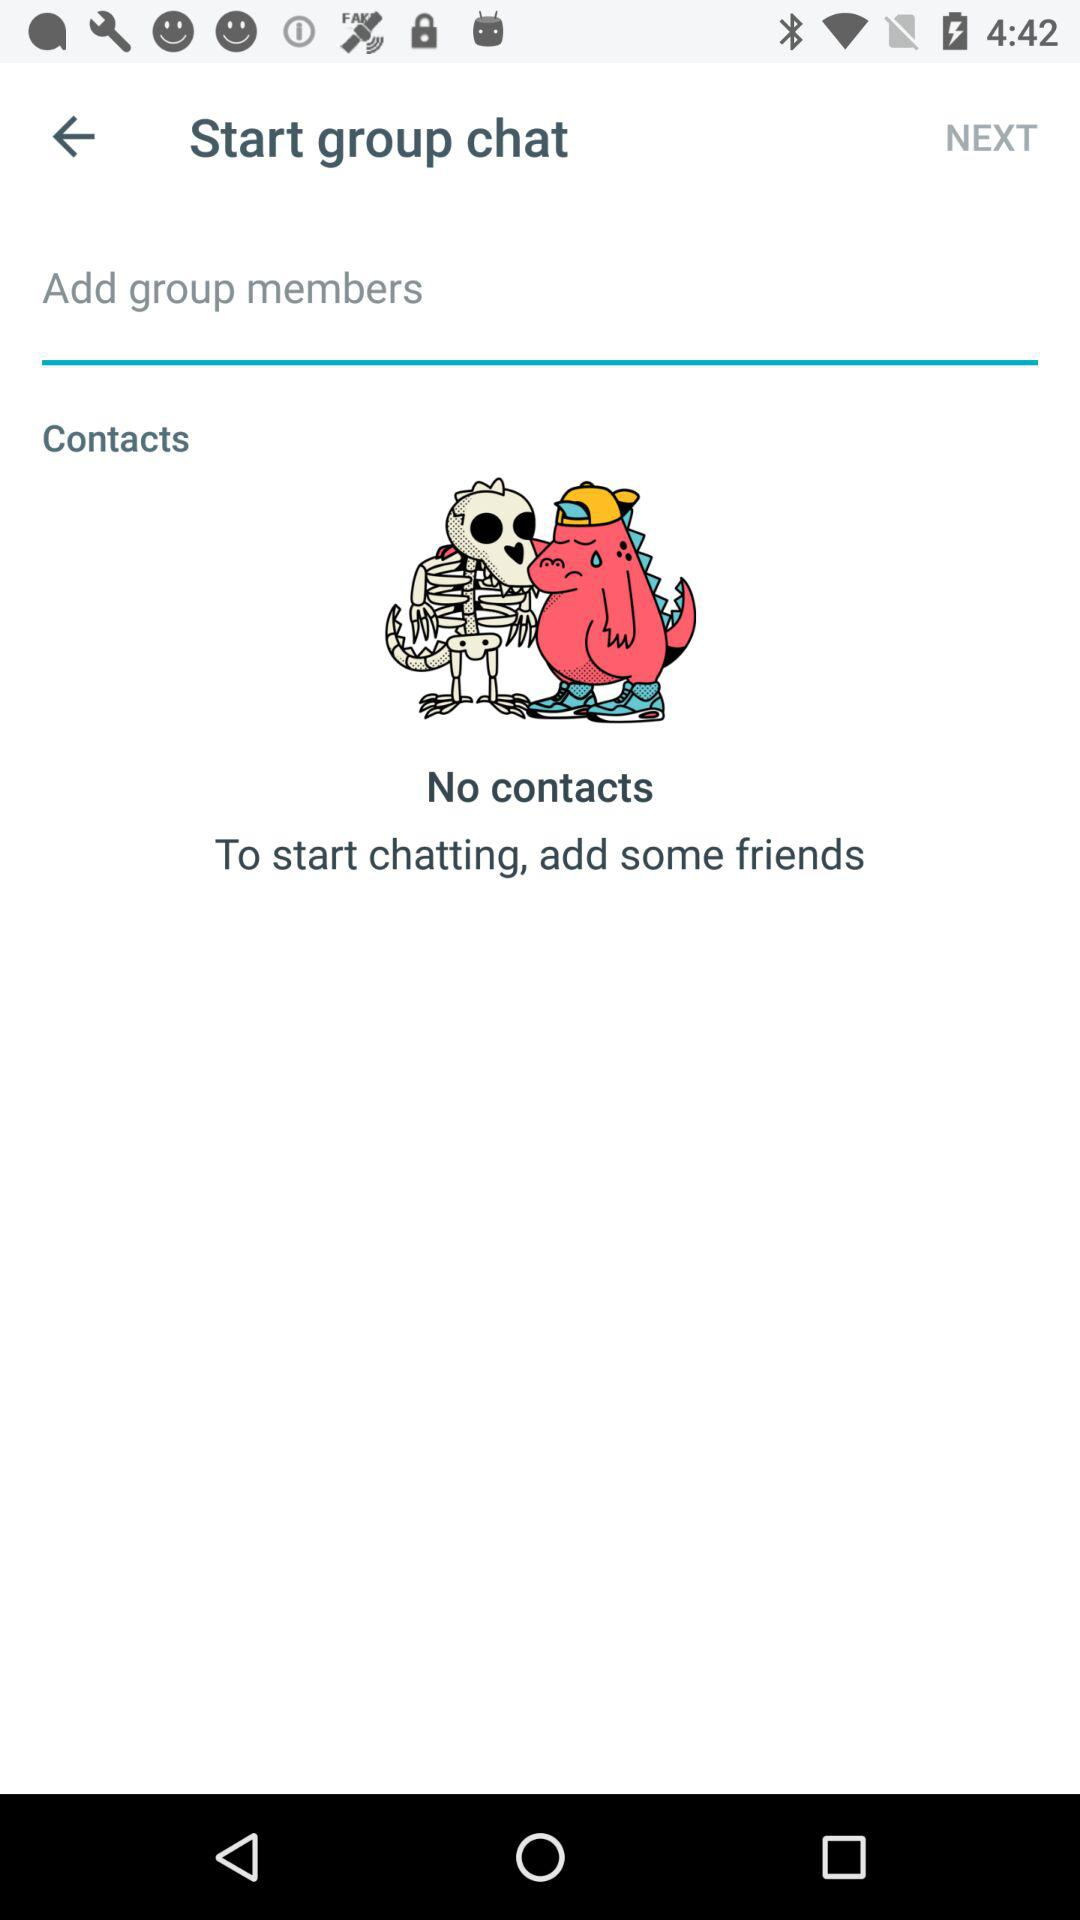Is there any contact? There are no contacts. 